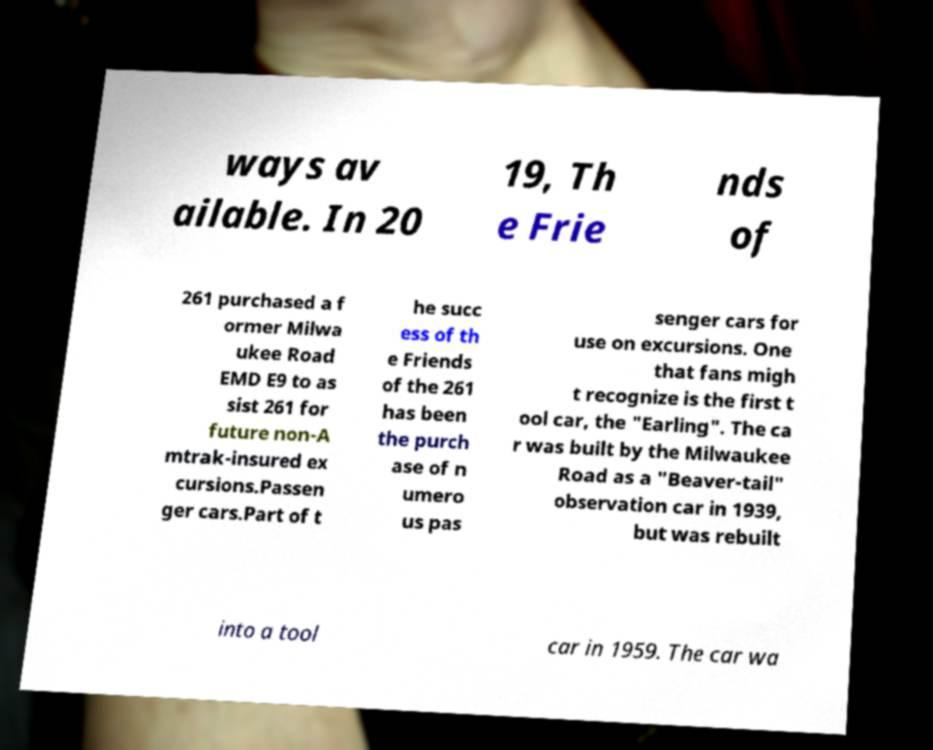Could you extract and type out the text from this image? ways av ailable. In 20 19, Th e Frie nds of 261 purchased a f ormer Milwa ukee Road EMD E9 to as sist 261 for future non-A mtrak-insured ex cursions.Passen ger cars.Part of t he succ ess of th e Friends of the 261 has been the purch ase of n umero us pas senger cars for use on excursions. One that fans migh t recognize is the first t ool car, the "Earling". The ca r was built by the Milwaukee Road as a "Beaver-tail" observation car in 1939, but was rebuilt into a tool car in 1959. The car wa 